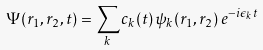<formula> <loc_0><loc_0><loc_500><loc_500>\Psi ( { r } _ { 1 } , { r } _ { 2 } , t ) = \sum _ { k } c _ { k } ( t ) \, \psi _ { k } ( { r } _ { 1 } , { r } _ { 2 } ) \, e ^ { - i \epsilon _ { k } t }</formula> 